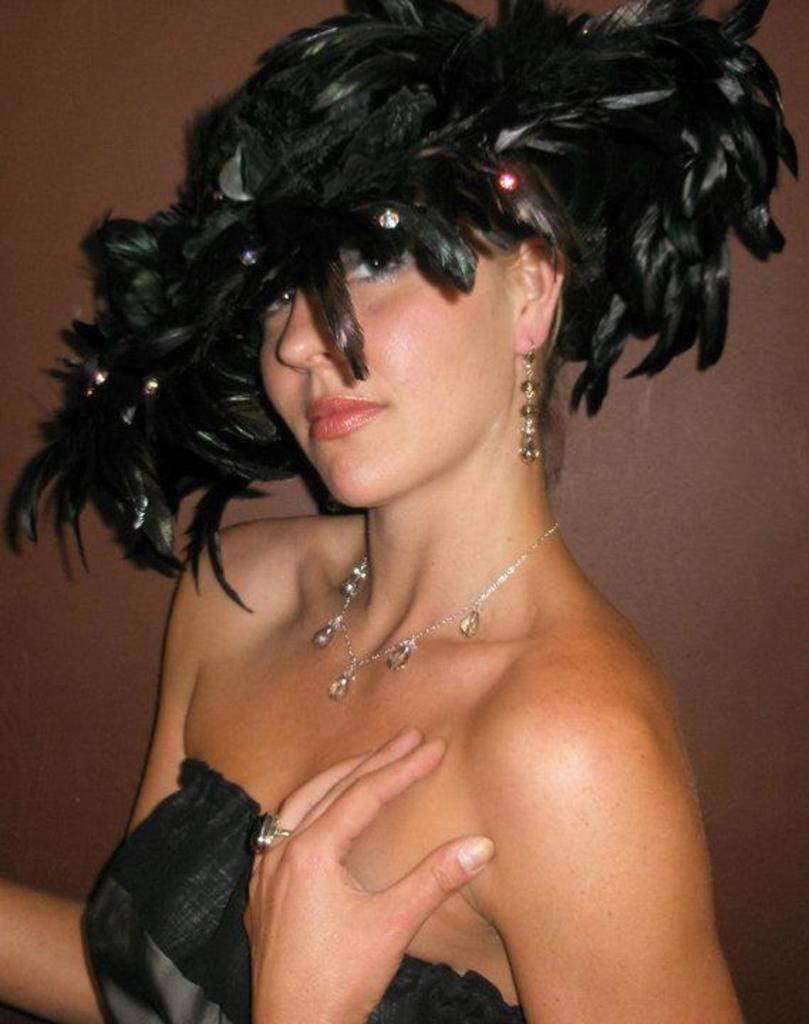Could you give a brief overview of what you see in this image? In the center of the image we can see a lady is wearing a black dress, chain and feather crown. In the background of the image we can see the wall. 